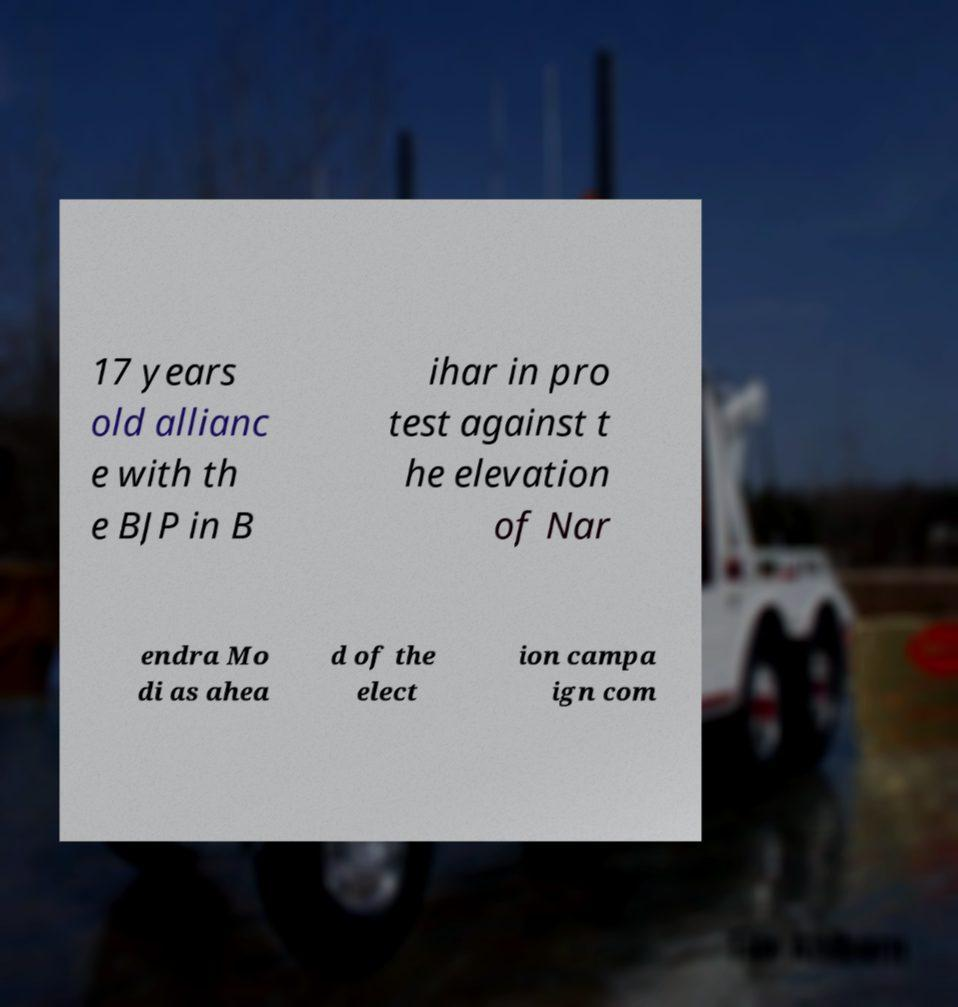What messages or text are displayed in this image? I need them in a readable, typed format. 17 years old allianc e with th e BJP in B ihar in pro test against t he elevation of Nar endra Mo di as ahea d of the elect ion campa ign com 